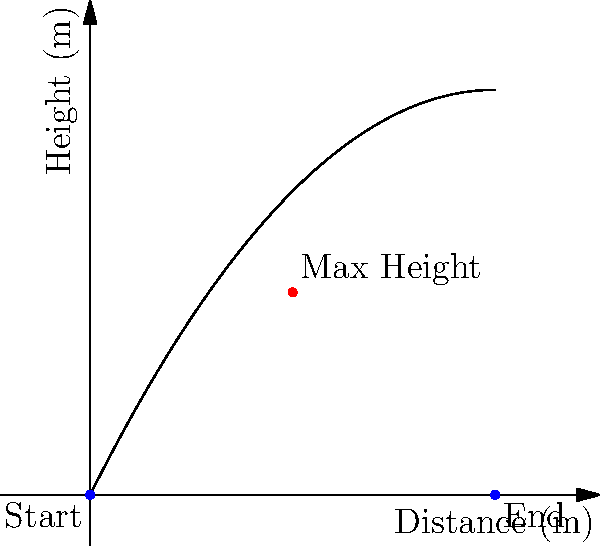In a hilarious ice-skating comedy sketch, you're tasked with calculating the trajectory of a thrown prop. The prop's path follows a parabolic curve, as shown in the graph. If the maximum height of the prop is 5 meters and it lands 10 meters away from its starting point, what is the initial velocity vector of the prop, assuming it was thrown at a 45-degree angle? Let's approach this step-by-step:

1) The parabolic equation for a projectile motion is:
   $y = -\frac{g}{2v_0^2\cos^2\theta}x^2 + x\tan\theta$

2) We know:
   - Maximum height (h) = 5 m
   - Range (R) = 10 m
   - Angle (θ) = 45°

3) For a 45° angle, $\sin\theta = \cos\theta = \frac{1}{\sqrt{2}}$

4) The range equation is:
   $R = \frac{v_0^2\sin(2\theta)}{g}$

5) Substituting our values:
   $10 = \frac{v_0^2\sin(90°)}{9.8} = \frac{v_0^2}{9.8}$

6) Solving for $v_0$:
   $v_0 = \sqrt{10 * 9.8} = \sqrt{98} \approx 9.9$ m/s

7) The initial velocity vector components are:
   $v_x = v_0\cos\theta = 9.9 * \frac{1}{\sqrt{2}} \approx 7$ m/s
   $v_y = v_0\sin\theta = 9.9 * \frac{1}{\sqrt{2}} \approx 7$ m/s

8) Therefore, the initial velocity vector is approximately:
   $\vec{v} = (7\hat{i} + 7\hat{j})$ m/s
Answer: $\vec{v} \approx (7\hat{i} + 7\hat{j})$ m/s 